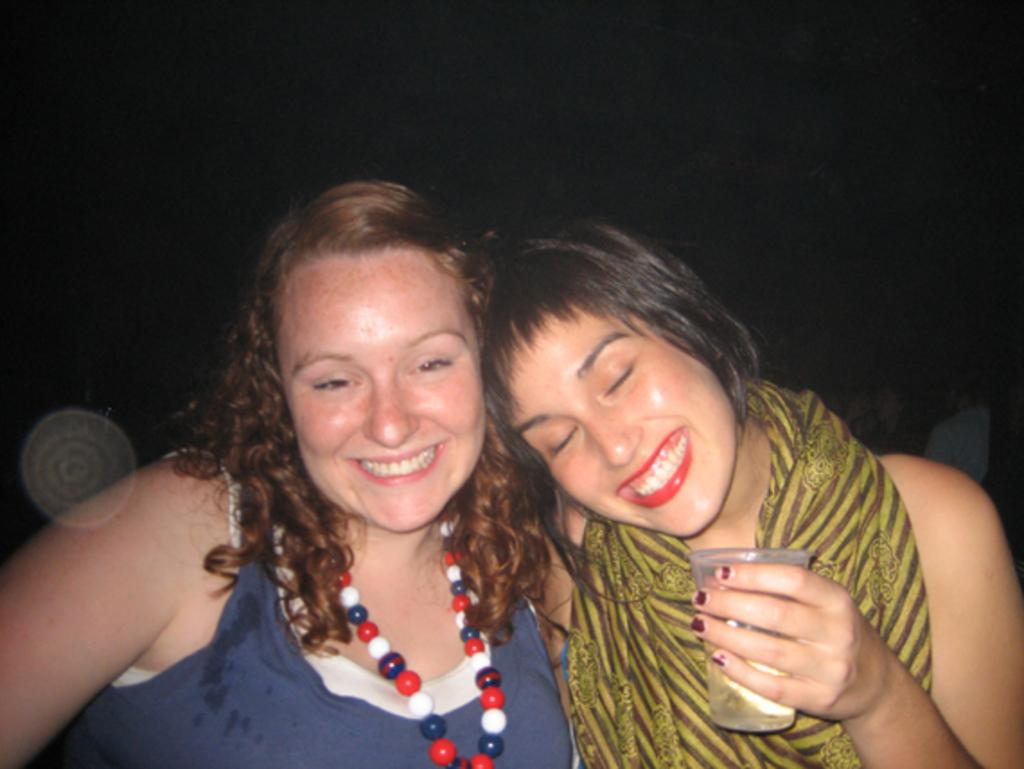How many people are in the image? There are two persons in the image. What are the expressions on their faces? Both persons are smiling in the image are smiling. What is one person holding in the image? There is a person holding a glass in the image. What can be observed about the background of the image? The background of the image is dark. What type of government is depicted in the image? There is no depiction of a government in the image; it features two smiling people and a person holding a glass. Can you tell me how many lakes are visible in the image? There are no lakes visible in the image. 